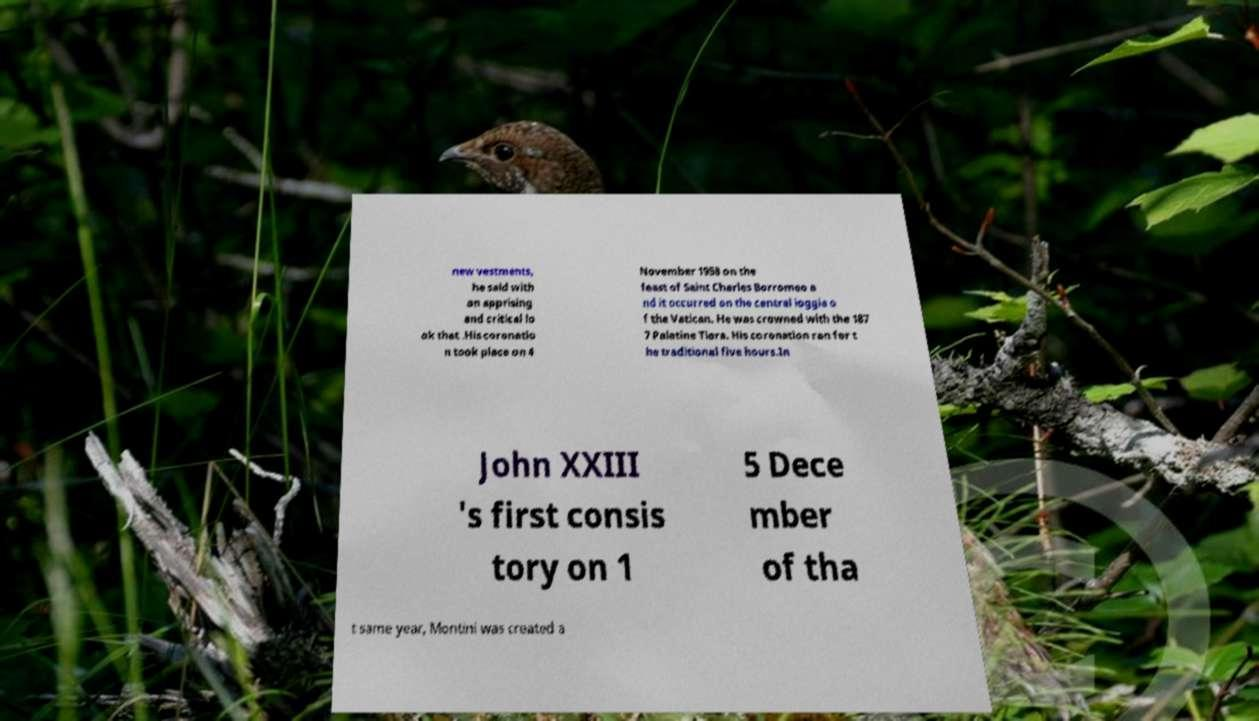Could you extract and type out the text from this image? new vestments, he said with an apprising and critical lo ok that .His coronatio n took place on 4 November 1958 on the feast of Saint Charles Borromeo a nd it occurred on the central loggia o f the Vatican. He was crowned with the 187 7 Palatine Tiara. His coronation ran for t he traditional five hours.In John XXIII 's first consis tory on 1 5 Dece mber of tha t same year, Montini was created a 